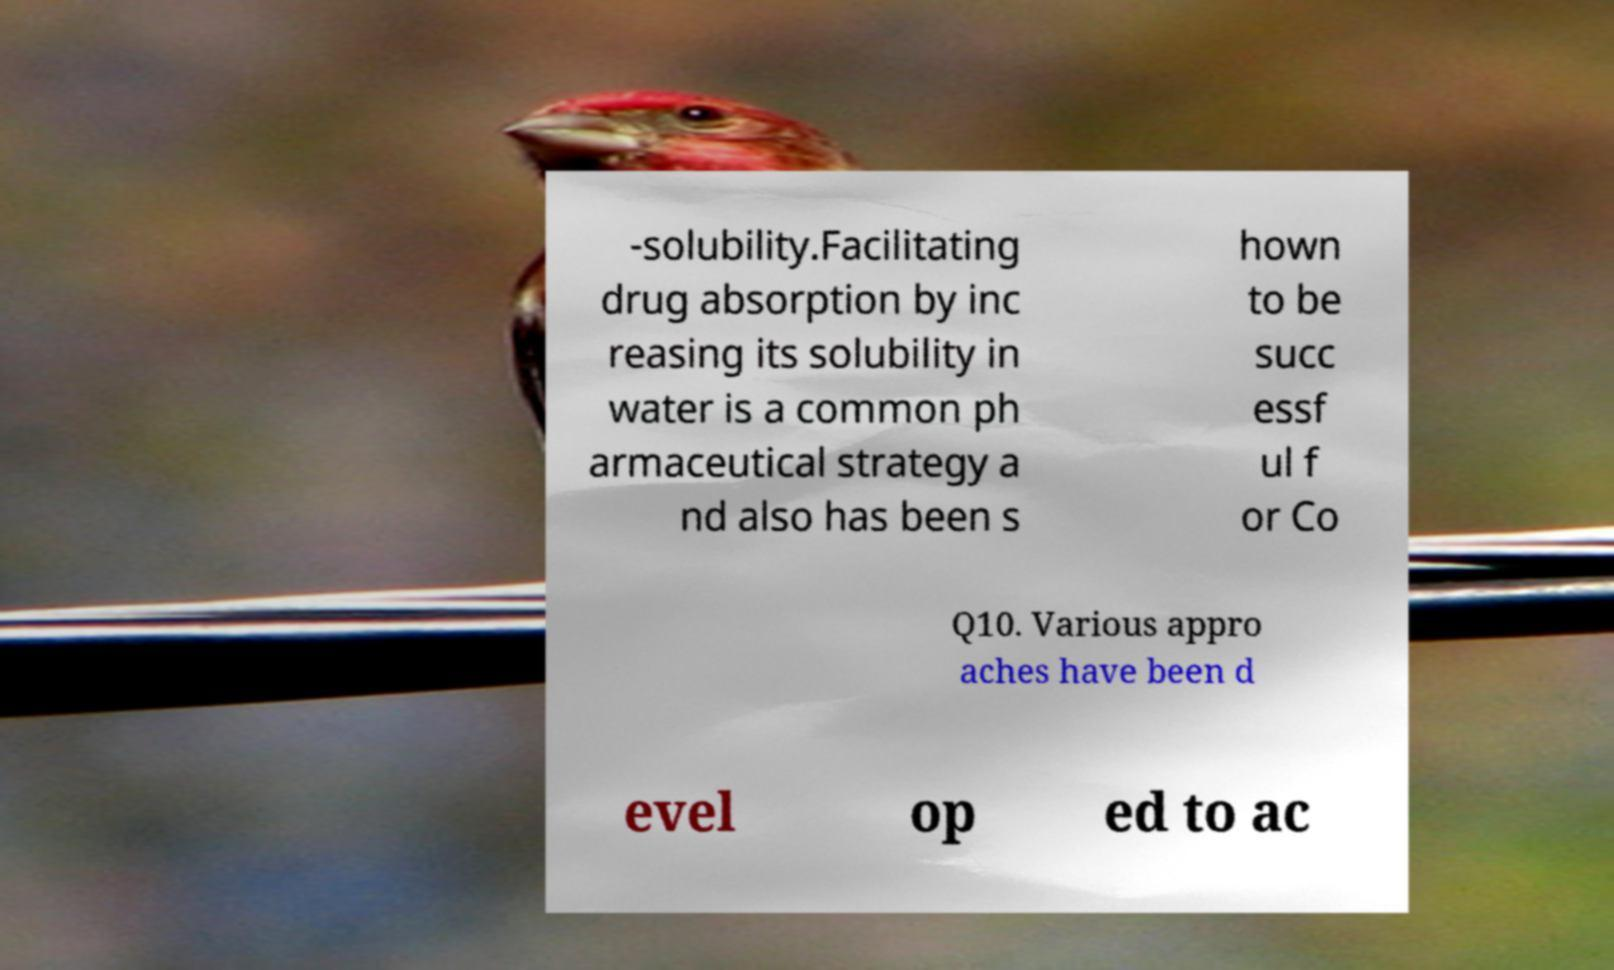There's text embedded in this image that I need extracted. Can you transcribe it verbatim? -solubility.Facilitating drug absorption by inc reasing its solubility in water is a common ph armaceutical strategy a nd also has been s hown to be succ essf ul f or Co Q10. Various appro aches have been d evel op ed to ac 